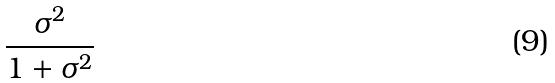Convert formula to latex. <formula><loc_0><loc_0><loc_500><loc_500>\frac { \sigma ^ { 2 } } { 1 + \sigma ^ { 2 } }</formula> 